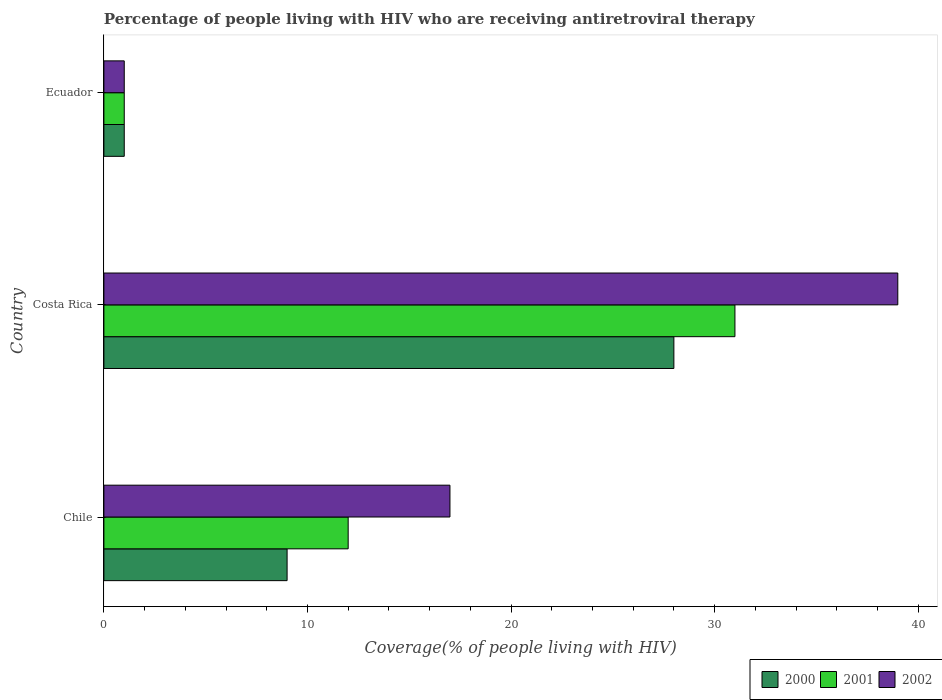How many different coloured bars are there?
Your answer should be very brief. 3. How many groups of bars are there?
Make the answer very short. 3. Are the number of bars per tick equal to the number of legend labels?
Your response must be concise. Yes. Are the number of bars on each tick of the Y-axis equal?
Provide a short and direct response. Yes. What is the label of the 1st group of bars from the top?
Give a very brief answer. Ecuador. What is the percentage of the HIV infected people who are receiving antiretroviral therapy in 2000 in Ecuador?
Your answer should be compact. 1. Across all countries, what is the minimum percentage of the HIV infected people who are receiving antiretroviral therapy in 2001?
Your response must be concise. 1. In which country was the percentage of the HIV infected people who are receiving antiretroviral therapy in 2001 minimum?
Keep it short and to the point. Ecuador. What is the difference between the percentage of the HIV infected people who are receiving antiretroviral therapy in 2001 in Chile and that in Costa Rica?
Offer a terse response. -19. What is the difference between the percentage of the HIV infected people who are receiving antiretroviral therapy in 2000 in Chile and the percentage of the HIV infected people who are receiving antiretroviral therapy in 2002 in Costa Rica?
Make the answer very short. -30. What is the average percentage of the HIV infected people who are receiving antiretroviral therapy in 2001 per country?
Ensure brevity in your answer.  14.67. What is the ratio of the percentage of the HIV infected people who are receiving antiretroviral therapy in 2000 in Chile to that in Costa Rica?
Offer a very short reply. 0.32. Is the percentage of the HIV infected people who are receiving antiretroviral therapy in 2001 in Costa Rica less than that in Ecuador?
Your answer should be compact. No. Is the difference between the percentage of the HIV infected people who are receiving antiretroviral therapy in 2001 in Costa Rica and Ecuador greater than the difference between the percentage of the HIV infected people who are receiving antiretroviral therapy in 2002 in Costa Rica and Ecuador?
Keep it short and to the point. No. What is the difference between the highest and the lowest percentage of the HIV infected people who are receiving antiretroviral therapy in 2001?
Your answer should be compact. 30. What does the 1st bar from the bottom in Ecuador represents?
Make the answer very short. 2000. Are all the bars in the graph horizontal?
Make the answer very short. Yes. What is the difference between two consecutive major ticks on the X-axis?
Give a very brief answer. 10. Are the values on the major ticks of X-axis written in scientific E-notation?
Keep it short and to the point. No. Does the graph contain any zero values?
Give a very brief answer. No. How many legend labels are there?
Keep it short and to the point. 3. What is the title of the graph?
Keep it short and to the point. Percentage of people living with HIV who are receiving antiretroviral therapy. Does "1981" appear as one of the legend labels in the graph?
Make the answer very short. No. What is the label or title of the X-axis?
Provide a short and direct response. Coverage(% of people living with HIV). What is the label or title of the Y-axis?
Offer a terse response. Country. What is the Coverage(% of people living with HIV) of 2001 in Chile?
Ensure brevity in your answer.  12. What is the Coverage(% of people living with HIV) in 2000 in Costa Rica?
Your answer should be very brief. 28. What is the Coverage(% of people living with HIV) in 2002 in Costa Rica?
Give a very brief answer. 39. What is the Coverage(% of people living with HIV) of 2001 in Ecuador?
Offer a very short reply. 1. What is the Coverage(% of people living with HIV) of 2002 in Ecuador?
Your answer should be compact. 1. Across all countries, what is the minimum Coverage(% of people living with HIV) in 2001?
Ensure brevity in your answer.  1. Across all countries, what is the minimum Coverage(% of people living with HIV) in 2002?
Keep it short and to the point. 1. What is the total Coverage(% of people living with HIV) of 2002 in the graph?
Make the answer very short. 57. What is the difference between the Coverage(% of people living with HIV) in 2000 in Chile and that in Costa Rica?
Offer a very short reply. -19. What is the difference between the Coverage(% of people living with HIV) of 2002 in Chile and that in Costa Rica?
Keep it short and to the point. -22. What is the difference between the Coverage(% of people living with HIV) in 2000 in Chile and that in Ecuador?
Your answer should be compact. 8. What is the difference between the Coverage(% of people living with HIV) in 2001 in Costa Rica and that in Ecuador?
Provide a short and direct response. 30. What is the difference between the Coverage(% of people living with HIV) in 2002 in Costa Rica and that in Ecuador?
Provide a succinct answer. 38. What is the difference between the Coverage(% of people living with HIV) of 2000 in Chile and the Coverage(% of people living with HIV) of 2001 in Costa Rica?
Offer a terse response. -22. What is the difference between the Coverage(% of people living with HIV) in 2000 in Chile and the Coverage(% of people living with HIV) in 2002 in Costa Rica?
Keep it short and to the point. -30. What is the difference between the Coverage(% of people living with HIV) of 2000 in Chile and the Coverage(% of people living with HIV) of 2001 in Ecuador?
Make the answer very short. 8. What is the difference between the Coverage(% of people living with HIV) in 2000 in Costa Rica and the Coverage(% of people living with HIV) in 2001 in Ecuador?
Offer a very short reply. 27. What is the average Coverage(% of people living with HIV) in 2000 per country?
Your answer should be compact. 12.67. What is the average Coverage(% of people living with HIV) of 2001 per country?
Offer a very short reply. 14.67. What is the average Coverage(% of people living with HIV) of 2002 per country?
Make the answer very short. 19. What is the difference between the Coverage(% of people living with HIV) of 2000 and Coverage(% of people living with HIV) of 2002 in Chile?
Give a very brief answer. -8. What is the difference between the Coverage(% of people living with HIV) of 2000 and Coverage(% of people living with HIV) of 2001 in Costa Rica?
Give a very brief answer. -3. What is the difference between the Coverage(% of people living with HIV) in 2000 and Coverage(% of people living with HIV) in 2001 in Ecuador?
Your response must be concise. 0. What is the difference between the Coverage(% of people living with HIV) in 2000 and Coverage(% of people living with HIV) in 2002 in Ecuador?
Offer a terse response. 0. What is the difference between the Coverage(% of people living with HIV) of 2001 and Coverage(% of people living with HIV) of 2002 in Ecuador?
Provide a succinct answer. 0. What is the ratio of the Coverage(% of people living with HIV) in 2000 in Chile to that in Costa Rica?
Your answer should be very brief. 0.32. What is the ratio of the Coverage(% of people living with HIV) of 2001 in Chile to that in Costa Rica?
Your answer should be compact. 0.39. What is the ratio of the Coverage(% of people living with HIV) of 2002 in Chile to that in Costa Rica?
Keep it short and to the point. 0.44. What is the ratio of the Coverage(% of people living with HIV) in 2000 in Chile to that in Ecuador?
Provide a succinct answer. 9. What is the ratio of the Coverage(% of people living with HIV) in 2001 in Chile to that in Ecuador?
Offer a terse response. 12. What is the ratio of the Coverage(% of people living with HIV) of 2000 in Costa Rica to that in Ecuador?
Give a very brief answer. 28. What is the difference between the highest and the second highest Coverage(% of people living with HIV) of 2000?
Offer a very short reply. 19. What is the difference between the highest and the second highest Coverage(% of people living with HIV) in 2002?
Give a very brief answer. 22. What is the difference between the highest and the lowest Coverage(% of people living with HIV) of 2000?
Your answer should be very brief. 27. 